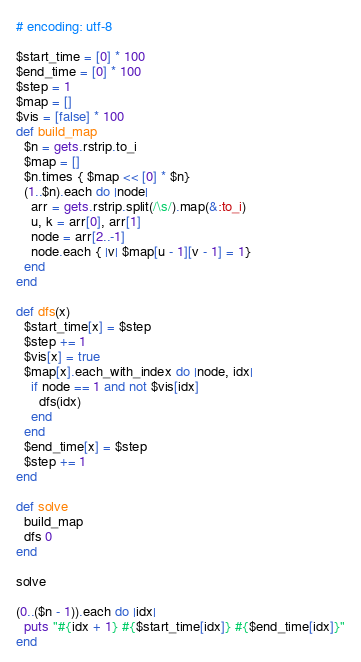Convert code to text. <code><loc_0><loc_0><loc_500><loc_500><_Ruby_># encoding: utf-8

$start_time = [0] * 100
$end_time = [0] * 100
$step = 1
$map = []
$vis = [false] * 100
def build_map
  $n = gets.rstrip.to_i
  $map = []
  $n.times { $map << [0] * $n}
  (1..$n).each do |node|
    arr = gets.rstrip.split(/\s/).map(&:to_i)
    u, k = arr[0], arr[1]
    node = arr[2..-1]
    node.each { |v| $map[u - 1][v - 1] = 1}
  end
end

def dfs(x)
  $start_time[x] = $step
  $step += 1
  $vis[x] = true
  $map[x].each_with_index do |node, idx|
    if node == 1 and not $vis[idx]
      dfs(idx)
    end
  end
  $end_time[x] = $step
  $step += 1
end

def solve
  build_map
  dfs 0
end

solve

(0..($n - 1)).each do |idx|
  puts "#{idx + 1} #{$start_time[idx]} #{$end_time[idx]}"
end</code> 